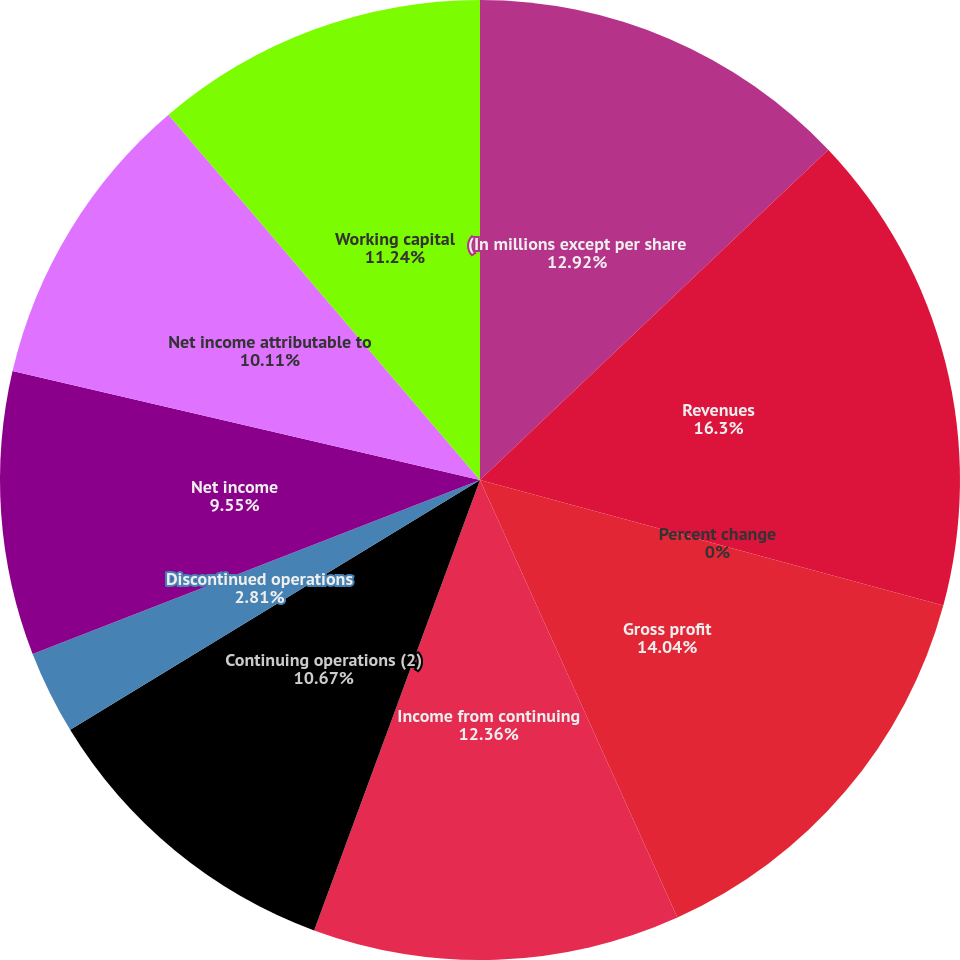<chart> <loc_0><loc_0><loc_500><loc_500><pie_chart><fcel>(In millions except per share<fcel>Revenues<fcel>Percent change<fcel>Gross profit<fcel>Income from continuing<fcel>Continuing operations (2)<fcel>Discontinued operations<fcel>Net income<fcel>Net income attributable to<fcel>Working capital<nl><fcel>12.92%<fcel>16.29%<fcel>0.0%<fcel>14.04%<fcel>12.36%<fcel>10.67%<fcel>2.81%<fcel>9.55%<fcel>10.11%<fcel>11.24%<nl></chart> 